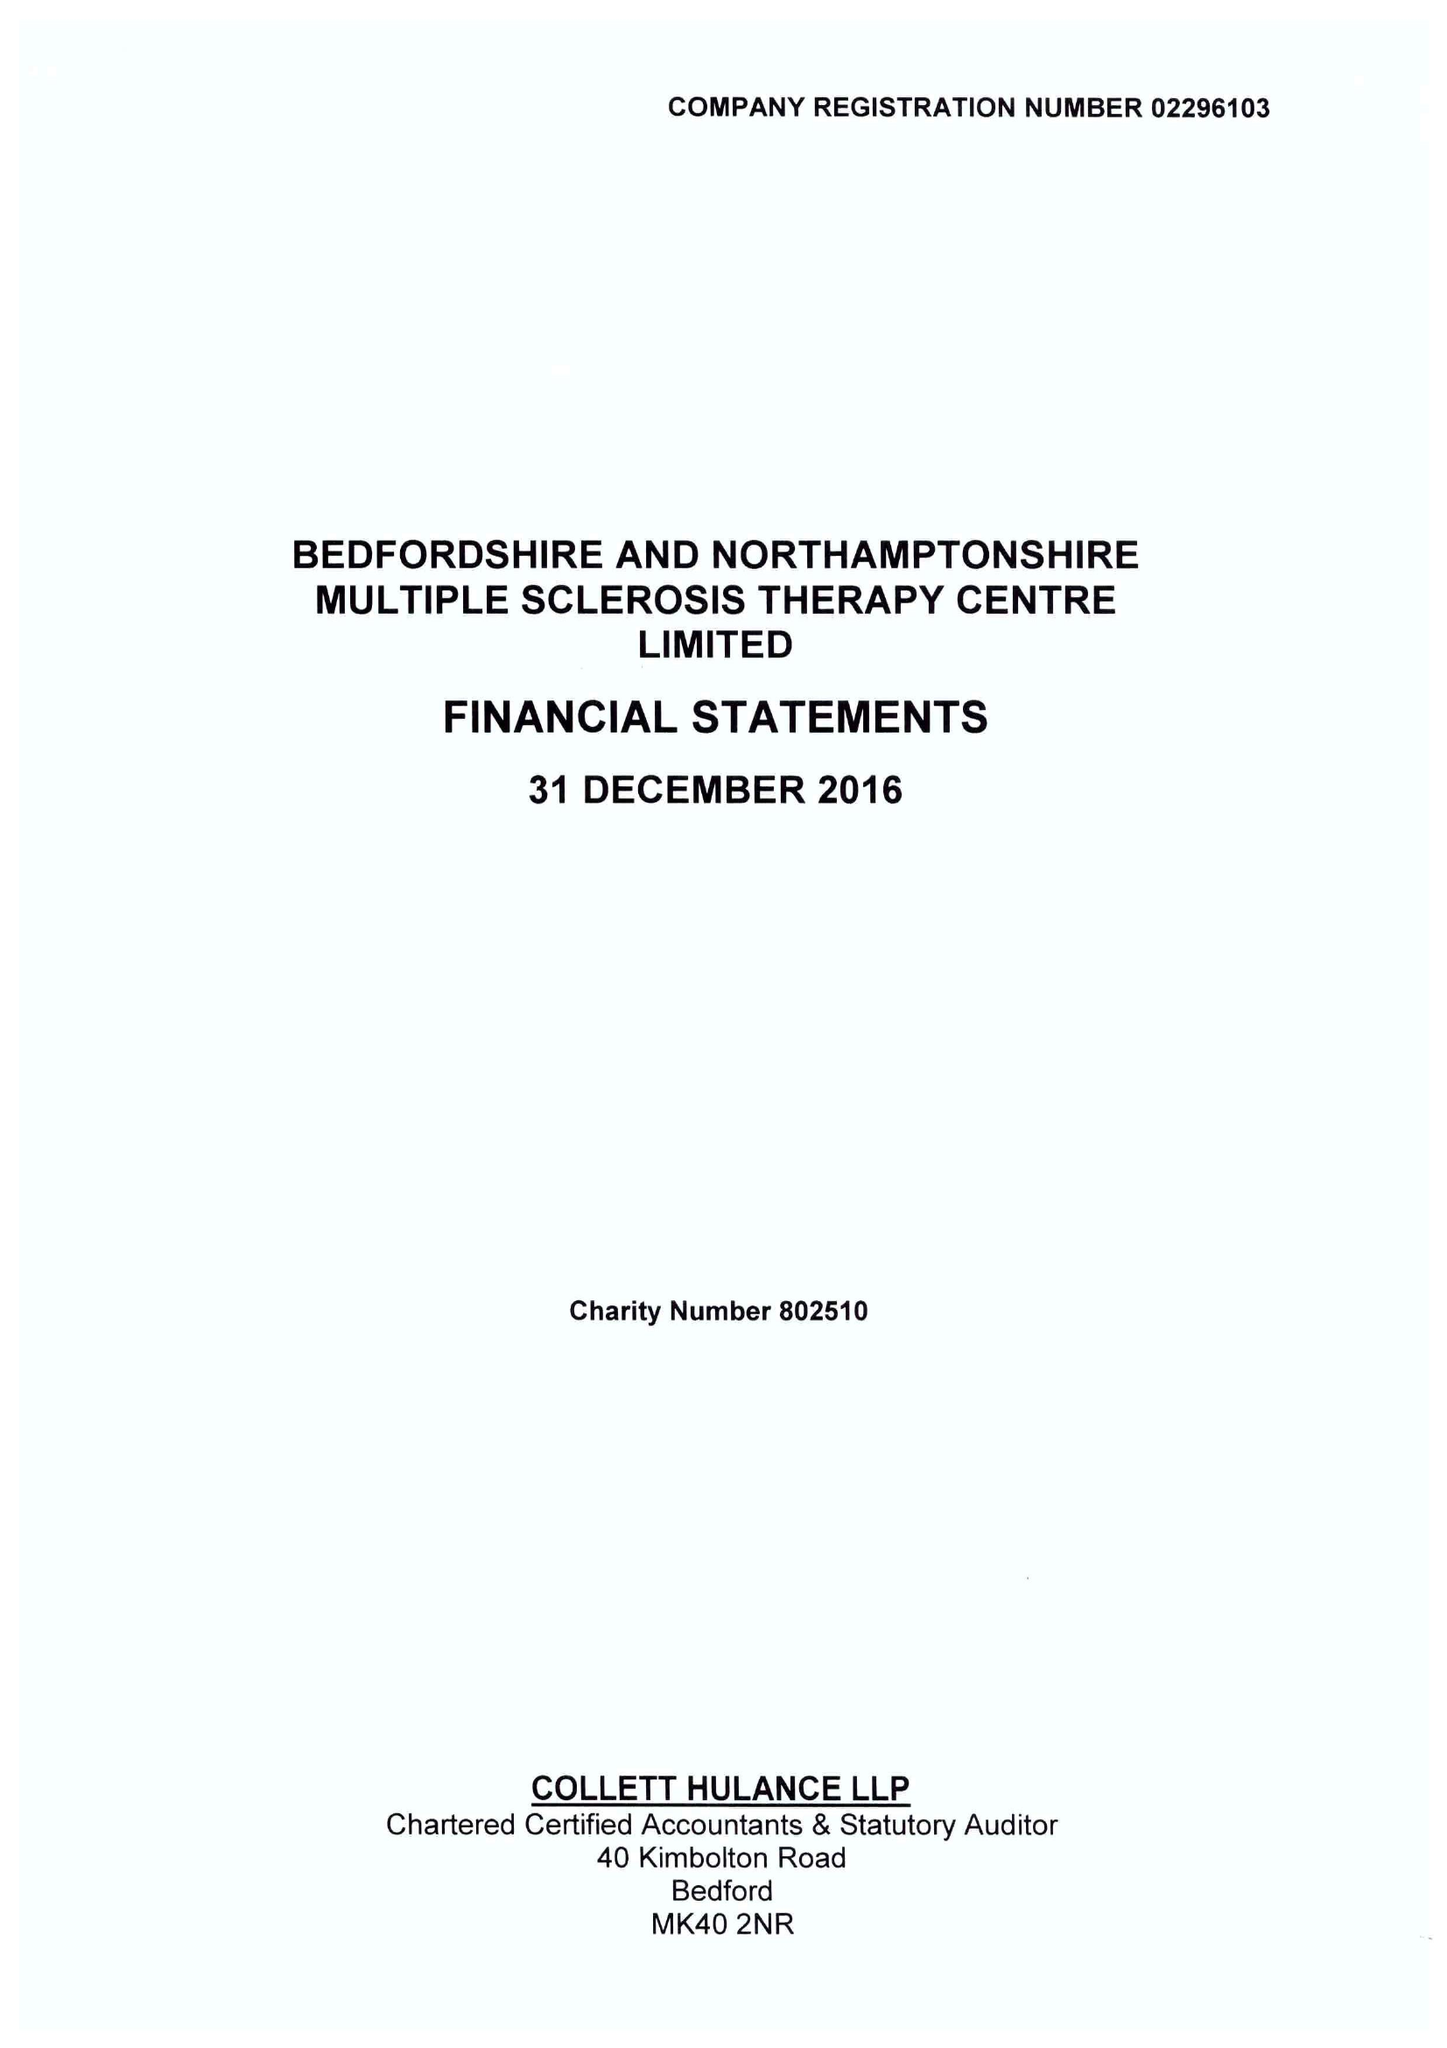What is the value for the charity_number?
Answer the question using a single word or phrase. 802510 